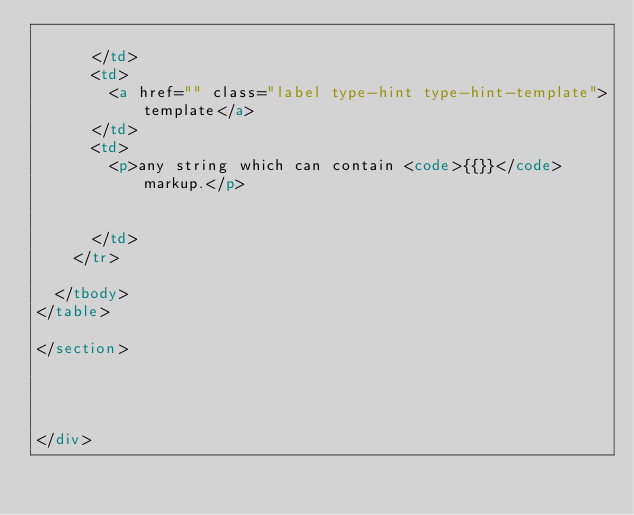Convert code to text. <code><loc_0><loc_0><loc_500><loc_500><_HTML_>        
      </td>
      <td>
        <a href="" class="label type-hint type-hint-template">template</a>
      </td>
      <td>
        <p>any string which can contain <code>{{}}</code> markup.</p>

        
      </td>
    </tr>
    
  </tbody>
</table>

</section>
  


  
</div>


</code> 